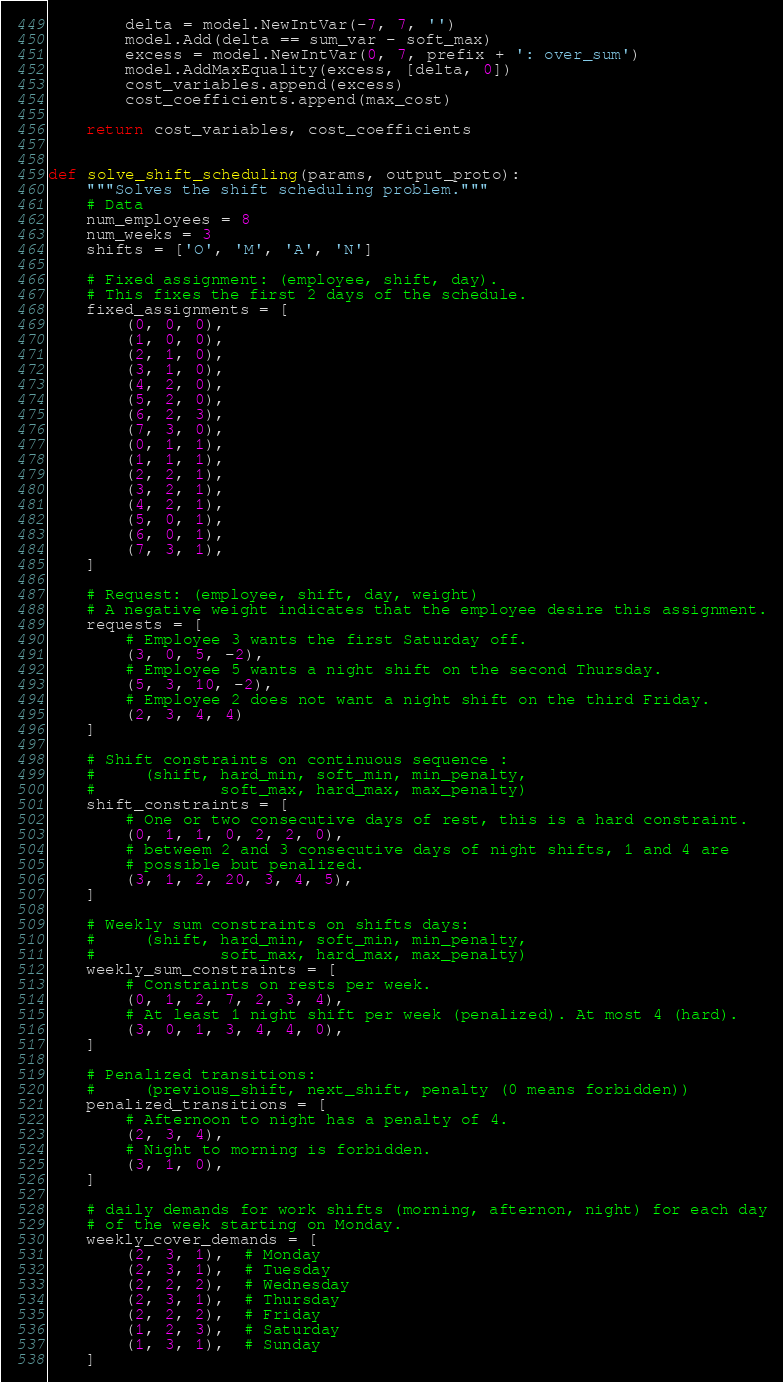<code> <loc_0><loc_0><loc_500><loc_500><_Python_>        delta = model.NewIntVar(-7, 7, '')
        model.Add(delta == sum_var - soft_max)
        excess = model.NewIntVar(0, 7, prefix + ': over_sum')
        model.AddMaxEquality(excess, [delta, 0])
        cost_variables.append(excess)
        cost_coefficients.append(max_cost)

    return cost_variables, cost_coefficients


def solve_shift_scheduling(params, output_proto):
    """Solves the shift scheduling problem."""
    # Data
    num_employees = 8
    num_weeks = 3
    shifts = ['O', 'M', 'A', 'N']

    # Fixed assignment: (employee, shift, day).
    # This fixes the first 2 days of the schedule.
    fixed_assignments = [
        (0, 0, 0),
        (1, 0, 0),
        (2, 1, 0),
        (3, 1, 0),
        (4, 2, 0),
        (5, 2, 0),
        (6, 2, 3),
        (7, 3, 0),
        (0, 1, 1),
        (1, 1, 1),
        (2, 2, 1),
        (3, 2, 1),
        (4, 2, 1),
        (5, 0, 1),
        (6, 0, 1),
        (7, 3, 1),
    ]

    # Request: (employee, shift, day, weight)
    # A negative weight indicates that the employee desire this assignment.
    requests = [
        # Employee 3 wants the first Saturday off.
        (3, 0, 5, -2),
        # Employee 5 wants a night shift on the second Thursday.
        (5, 3, 10, -2),
        # Employee 2 does not want a night shift on the third Friday.
        (2, 3, 4, 4)
    ]

    # Shift constraints on continuous sequence :
    #     (shift, hard_min, soft_min, min_penalty,
    #             soft_max, hard_max, max_penalty)
    shift_constraints = [
        # One or two consecutive days of rest, this is a hard constraint.
        (0, 1, 1, 0, 2, 2, 0),
        # betweem 2 and 3 consecutive days of night shifts, 1 and 4 are
        # possible but penalized.
        (3, 1, 2, 20, 3, 4, 5),
    ]

    # Weekly sum constraints on shifts days:
    #     (shift, hard_min, soft_min, min_penalty,
    #             soft_max, hard_max, max_penalty)
    weekly_sum_constraints = [
        # Constraints on rests per week.
        (0, 1, 2, 7, 2, 3, 4),
        # At least 1 night shift per week (penalized). At most 4 (hard).
        (3, 0, 1, 3, 4, 4, 0),
    ]

    # Penalized transitions:
    #     (previous_shift, next_shift, penalty (0 means forbidden))
    penalized_transitions = [
        # Afternoon to night has a penalty of 4.
        (2, 3, 4),
        # Night to morning is forbidden.
        (3, 1, 0),
    ]

    # daily demands for work shifts (morning, afternon, night) for each day
    # of the week starting on Monday.
    weekly_cover_demands = [
        (2, 3, 1),  # Monday
        (2, 3, 1),  # Tuesday
        (2, 2, 2),  # Wednesday
        (2, 3, 1),  # Thursday
        (2, 2, 2),  # Friday
        (1, 2, 3),  # Saturday
        (1, 3, 1),  # Sunday
    ]
</code> 